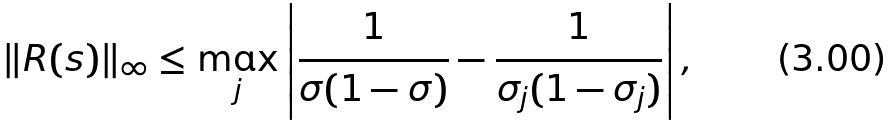Convert formula to latex. <formula><loc_0><loc_0><loc_500><loc_500>\| R ( s ) \| _ { \infty } \leq \max _ { j } \left | \frac { 1 } { \sigma ( 1 - \sigma ) } - \frac { 1 } { \sigma _ { j } ( 1 - \sigma _ { j } ) } \right | ,</formula> 